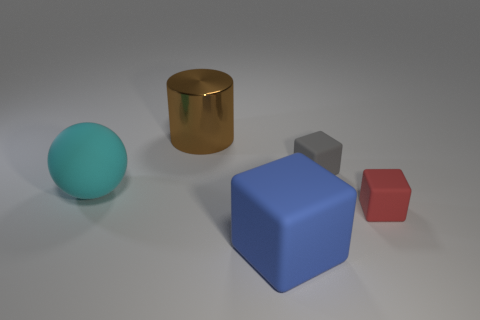Is the big sphere the same color as the metallic cylinder?
Give a very brief answer. No. Do the rubber thing that is to the left of the blue cube and the red thing have the same size?
Keep it short and to the point. No. There is a cube behind the object that is to the left of the large cylinder; are there any big cyan balls that are on the right side of it?
Keep it short and to the point. No. What number of matte things are either big cylinders or big brown balls?
Provide a short and direct response. 0. How many other objects are the same shape as the large cyan matte thing?
Your answer should be compact. 0. Are there more blue objects than purple shiny spheres?
Make the answer very short. Yes. There is a cube that is behind the large rubber object that is behind the big rubber object that is to the right of the big cylinder; what size is it?
Your answer should be very brief. Small. There is a gray block behind the large cyan ball; how big is it?
Offer a terse response. Small. What number of things are either cubes or cubes that are behind the big ball?
Offer a terse response. 3. What number of other objects are the same size as the gray rubber object?
Your answer should be very brief. 1. 